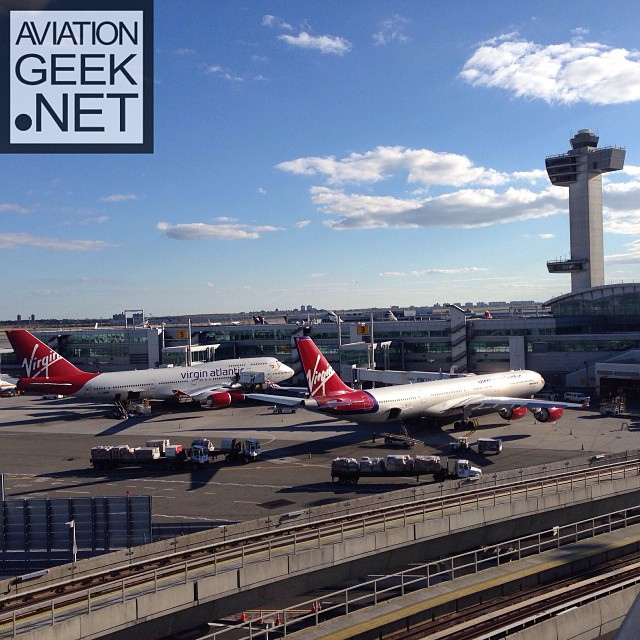Please transcribe the text information in this image. AVIATION GEEK NET Virgin virgin Virgin atlantic 